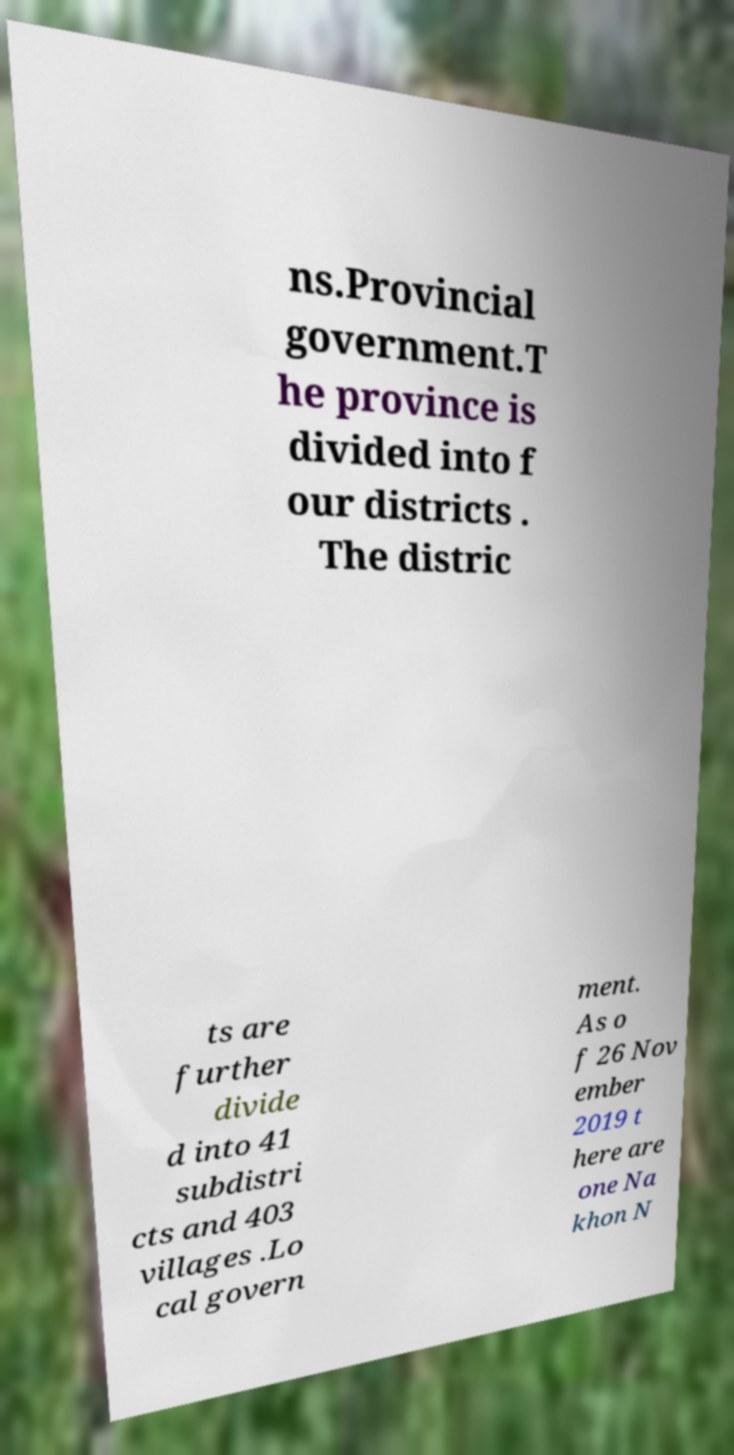Could you assist in decoding the text presented in this image and type it out clearly? ns.Provincial government.T he province is divided into f our districts . The distric ts are further divide d into 41 subdistri cts and 403 villages .Lo cal govern ment. As o f 26 Nov ember 2019 t here are one Na khon N 